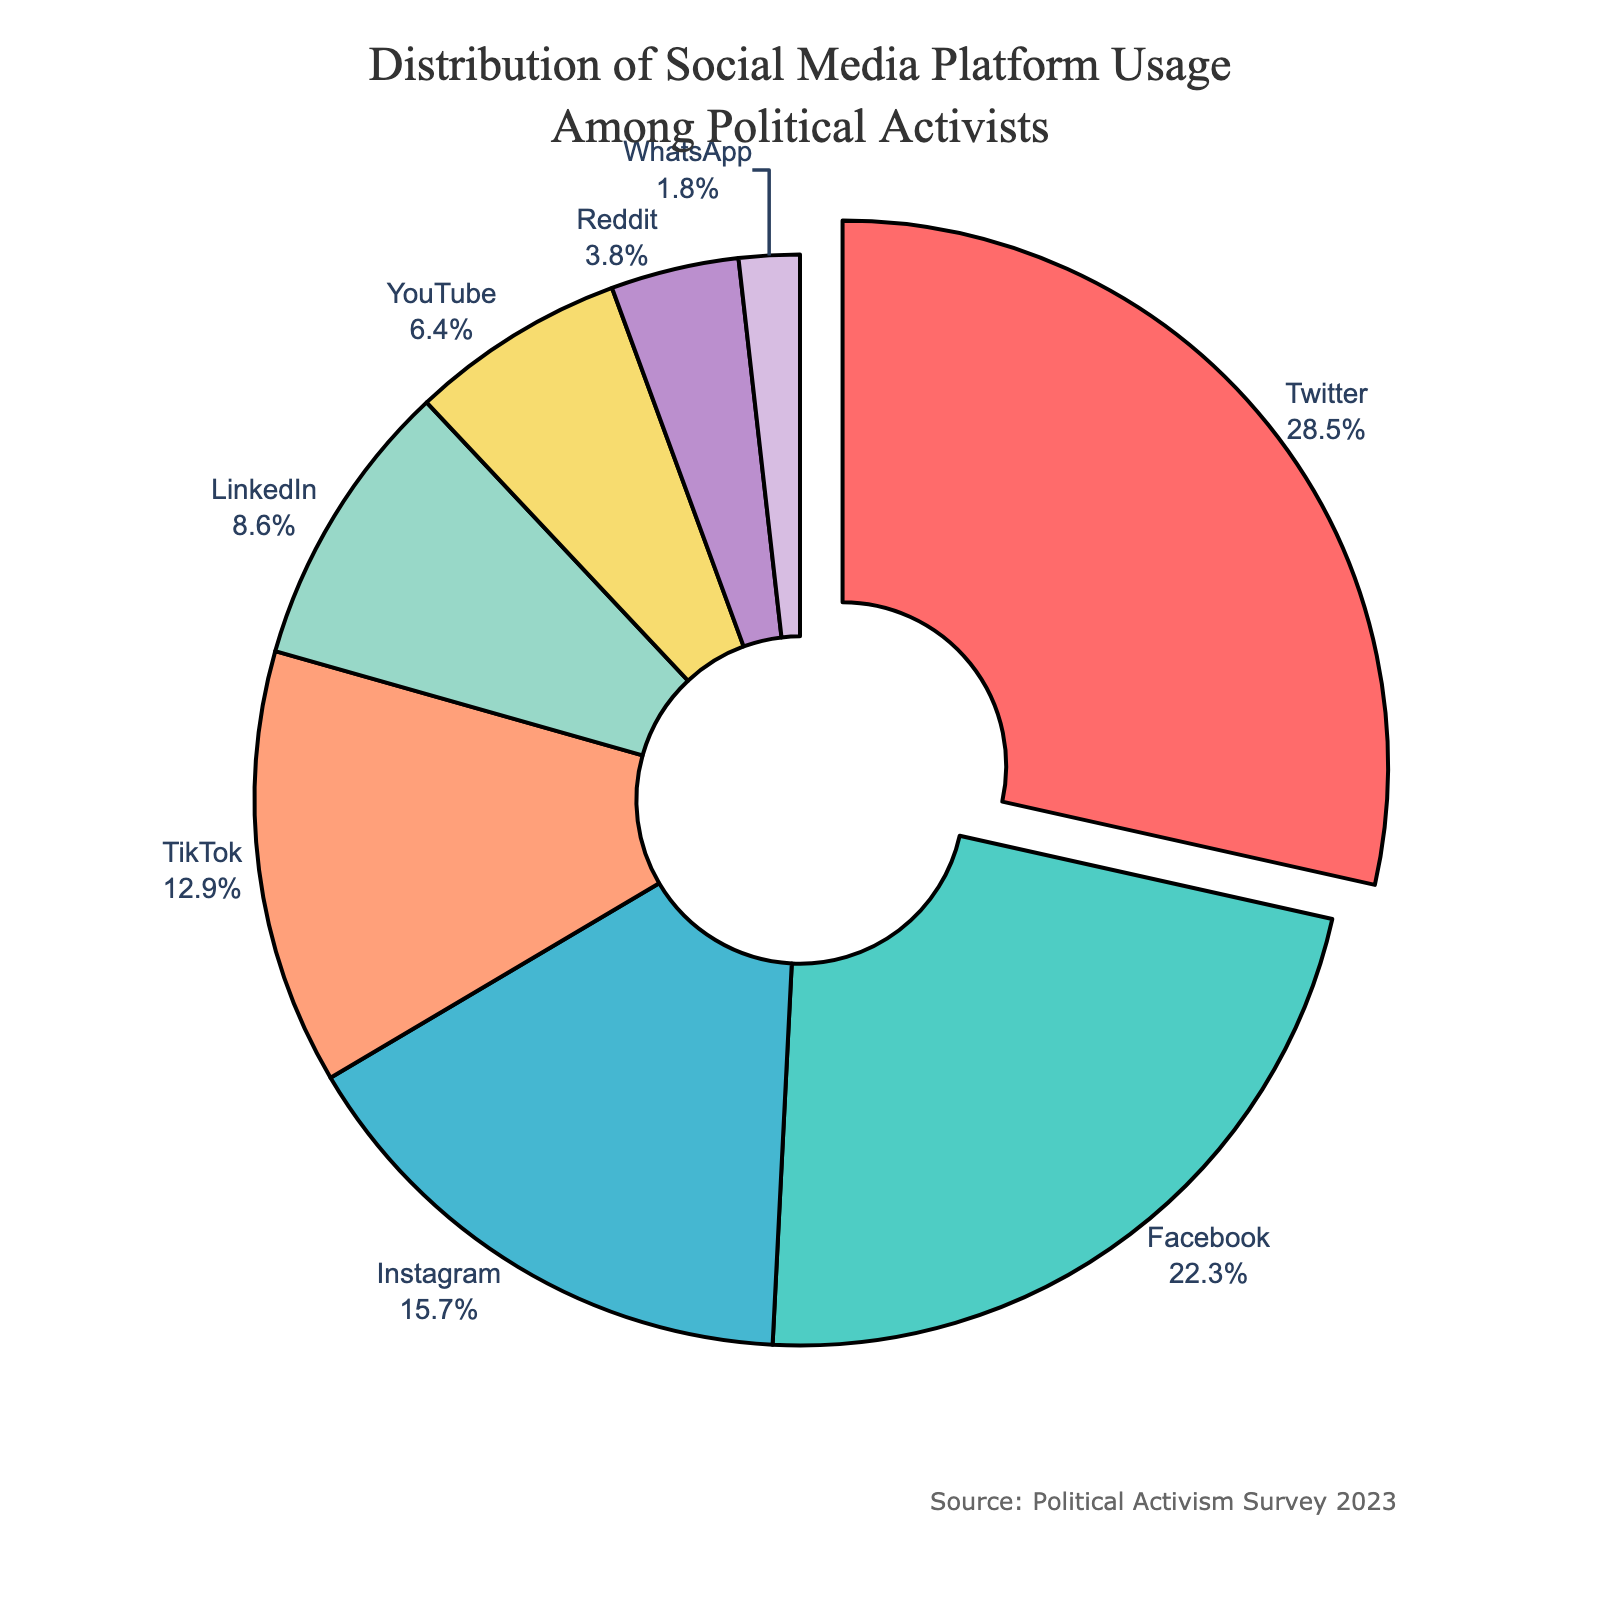What is the most used social media platform among political activists? The figure shows that Twitter has the largest segment with 28.5% of the distribution.
Answer: Twitter What platforms have a combined usage percentage lower than Instagram? Instagram has a usage percentage of 15.7%. Combining the percentages of YouTube (6.4%), Reddit (3.8%), and WhatsApp (1.8%) gives a total of 12%, which is lower than Instagram.
Answer: YouTube, Reddit, WhatsApp Which platform is used significantly less than TikTok but more than YouTube? LinkedIn's usage percentage is 8.6%, which is less than TikTok's 12.9% but more than YouTube's 6.4%.
Answer: LinkedIn What is the percentage difference between the highest and lowest used social media platforms? The highest usage percentage is Twitter with 28.5%, and the lowest is WhatsApp with 1.8%. The difference is 28.5% - 1.8% = 26.7%.
Answer: 26.7% Which platform is represented by a blue segment and what is its percentage usage? The figure shows that Instagram is represented by a blue segment with a percentage usage of 15.7%.
Answer: Instagram, 15.7% How much more prevalent is Facebook compared to LinkedIn among political activists? Facebook's usage percentage is 22.3%, and LinkedIn's is 8.6%. The difference is 22.3% - 8.6% = 13.7%.
Answer: 13.7% If we combine the usage percentages of TikTok, YouTube, and Reddit, what is their total? The percentages for TikTok, YouTube, and Reddit are 12.9%, 6.4%, and 3.8% respectively. Adding these gives 12.9% + 6.4% + 3.8% = 23.1%.
Answer: 23.1% Which two platforms have a combined usage similar to Facebook? Instagram has 15.7% and LinkedIn has 8.6%. Their combined usage is 15.7% + 8.6% = 24.3%, which is close to Facebook's 22.3%.
Answer: Instagram and LinkedIn What is the color of the segment with the smallest usage percentage? The figure shows that the segment representing WhatsApp has the smallest usage percentage of 1.8%, and it is light purple.
Answer: light purple 